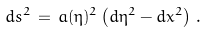<formula> <loc_0><loc_0><loc_500><loc_500>d s ^ { 2 } \, = \, a ( \eta ) ^ { 2 } \left ( d \eta ^ { 2 } - d { x } ^ { 2 } \right ) \, .</formula> 